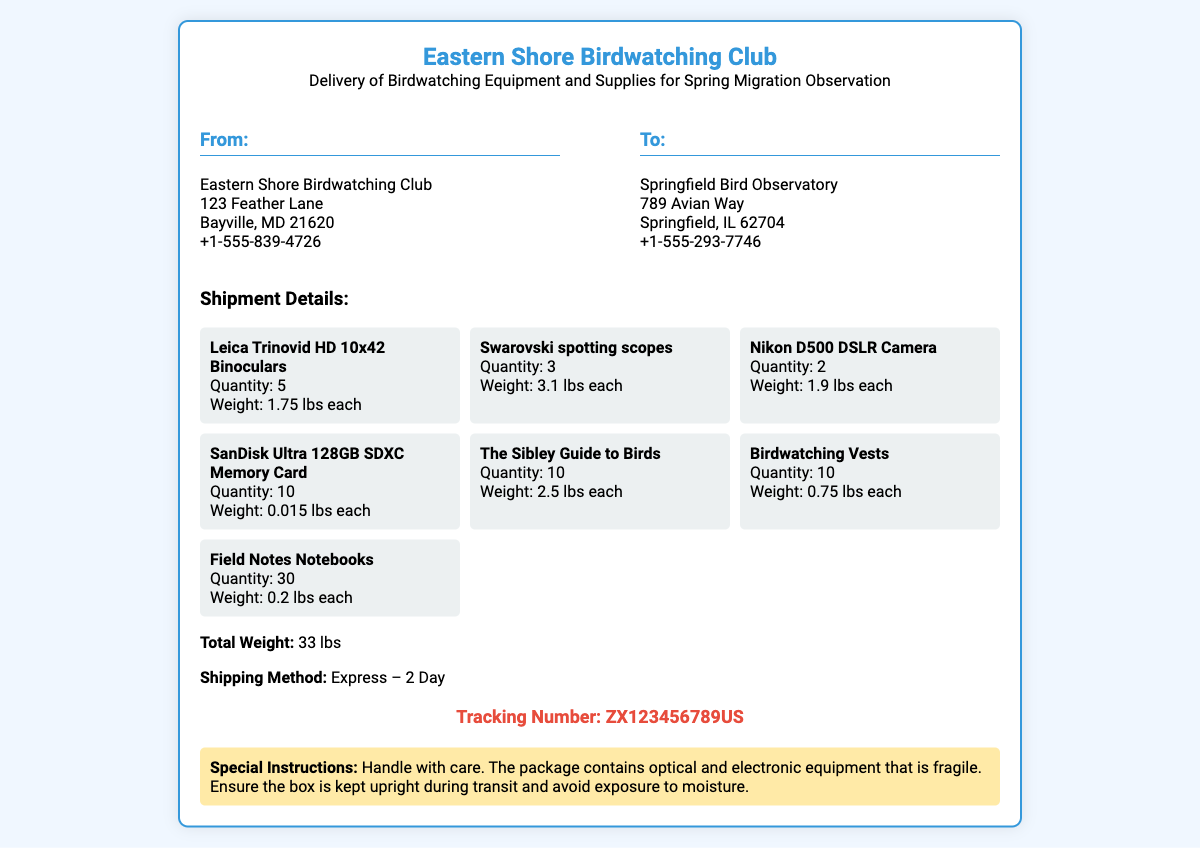What is the name of the sending organization? The sending organization is listed at the top of the document under "From:" as Eastern Shore Birdwatching Club.
Answer: Eastern Shore Birdwatching Club What is the weight of the Leica Trinovid HD binoculars? The weight of each binocular is specified in the shipment details section.
Answer: 1.75 lbs each How many Birdwatching Vests are included in the shipment? The quantity of Birdwatching Vests is stated in the item list.
Answer: 10 What is the total weight of the shipment? The total weight is concluded from the cumulative weight detail provided in the shipment section.
Answer: 33 lbs What is the tracking number for this shipment? The tracking number is provided at the bottom of the document, as indicated in the tracking section.
Answer: ZX123456789US What is the shipping method used for this delivery? The shipping method is mentioned in the shipment details section.
Answer: Express – 2 Day What should be done with the package according to special instructions? The special instructions section outlines the care needed during transit.
Answer: Handle with care How many Field Notes Notebooks are being shipped? The number of Field Notes Notebooks is specified in the item list.
Answer: 30 